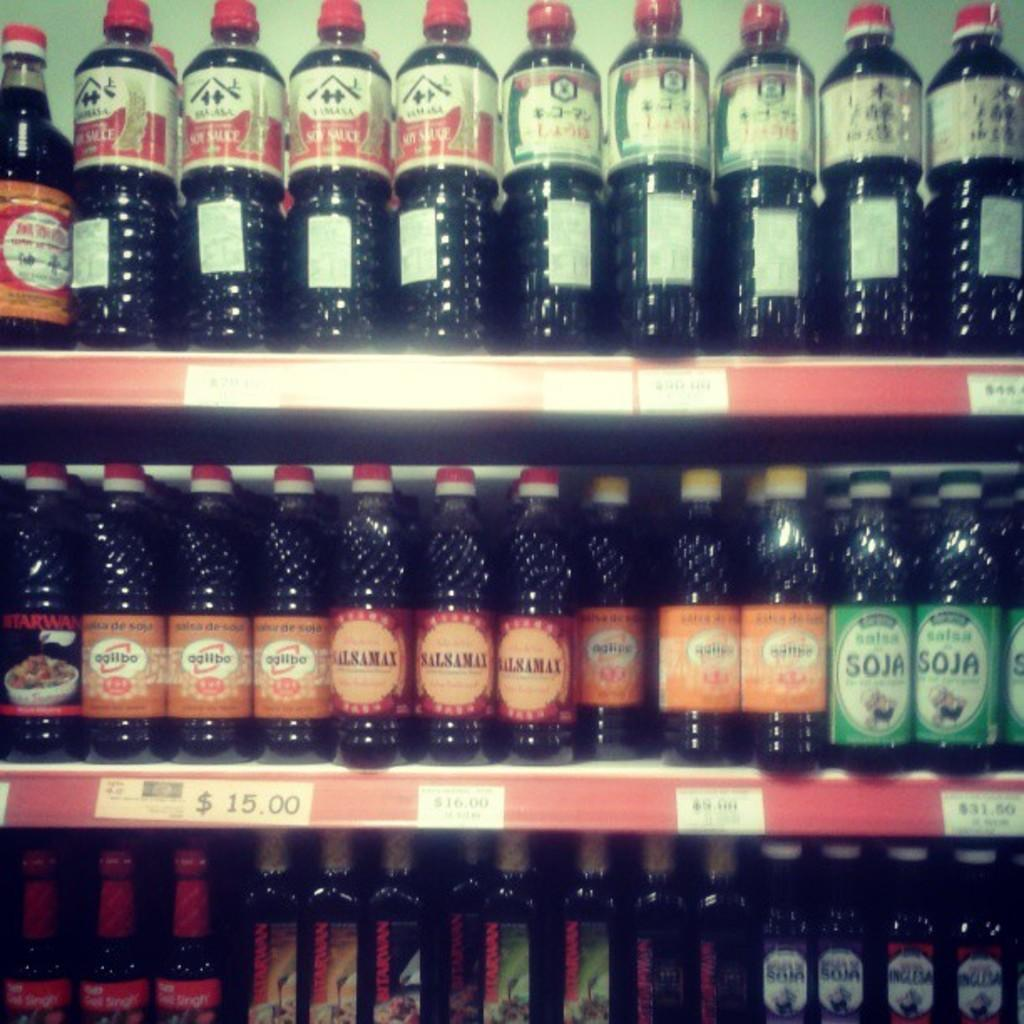Provide a one-sentence caption for the provided image. many soy and salsamax bottles on a shelf. 